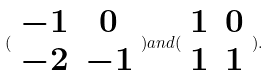Convert formula to latex. <formula><loc_0><loc_0><loc_500><loc_500>( \begin{array} { c c } - 1 & 0 \\ - 2 & - 1 \end{array} ) a n d ( \begin{array} { c c } 1 & 0 \\ 1 & 1 \end{array} ) .</formula> 